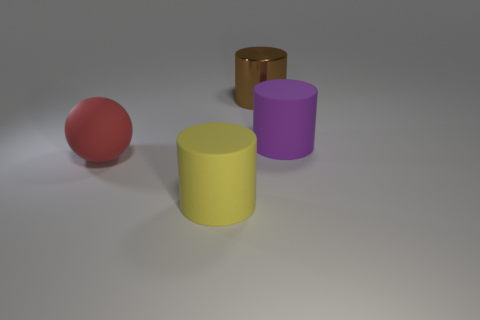Are there any cyan metallic blocks of the same size as the red rubber thing?
Make the answer very short. No. Is the large yellow rubber thing the same shape as the large metal thing?
Offer a very short reply. Yes. There is a cylinder that is to the left of the large cylinder that is behind the purple rubber thing; are there any large cylinders that are on the right side of it?
Your response must be concise. Yes. There is a rubber cylinder that is behind the large red object; does it have the same size as the rubber cylinder that is left of the shiny thing?
Your answer should be very brief. Yes. Is the number of red things that are on the left side of the large red rubber object the same as the number of large metal things right of the large purple thing?
Make the answer very short. Yes. Is there any other thing that is the same material as the red ball?
Offer a very short reply. Yes. There is a brown object; does it have the same size as the rubber cylinder that is left of the large metal cylinder?
Provide a succinct answer. Yes. What material is the cylinder behind the thing right of the brown cylinder?
Offer a terse response. Metal. Are there an equal number of brown things on the left side of the yellow cylinder and large rubber things?
Your answer should be very brief. No. There is a thing that is on the right side of the large red matte thing and to the left of the big brown object; what is its size?
Keep it short and to the point. Large. 